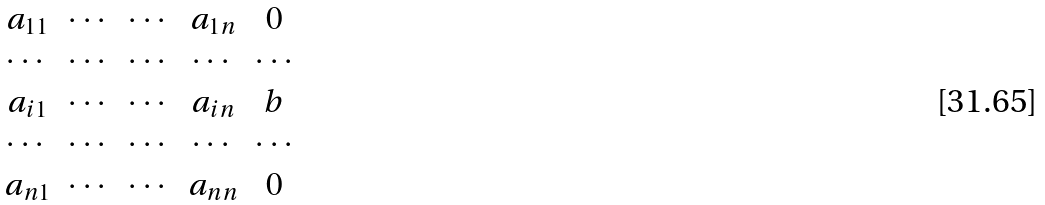Convert formula to latex. <formula><loc_0><loc_0><loc_500><loc_500>\begin{matrix} a _ { 1 1 } & \cdots & \cdots & a _ { 1 n } & 0 \\ \cdots & \cdots & \cdots & \cdots & \cdots \\ a _ { i 1 } & \cdots & \cdots & a _ { i n } & b \\ \cdots & \cdots & \cdots & \cdots & \cdots \\ a _ { n 1 } & \cdots & \cdots & a _ { n n } & 0 \end{matrix}</formula> 